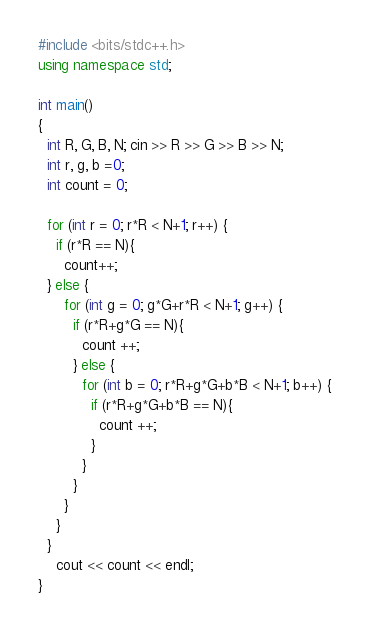Convert code to text. <code><loc_0><loc_0><loc_500><loc_500><_C++_>#include <bits/stdc++.h>
using namespace std;

int main()
{
  int R, G, B, N; cin >> R >> G >> B >> N;
  int r, g, b =0;
  int count = 0;
  
  for (int r = 0; r*R < N+1; r++) {
    if (r*R == N){
      count++;
  } else {
      for (int g = 0; g*G+r*R < N+1; g++) {
        if (r*R+g*G == N){
          count ++;
        } else {
          for (int b = 0; r*R+g*G+b*B < N+1; b++) {
            if (r*R+g*G+b*B == N){
              count ++;
            }
          }
        }
      }
    }
  }
    cout << count << endl;
}</code> 